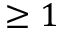<formula> <loc_0><loc_0><loc_500><loc_500>\geq 1</formula> 